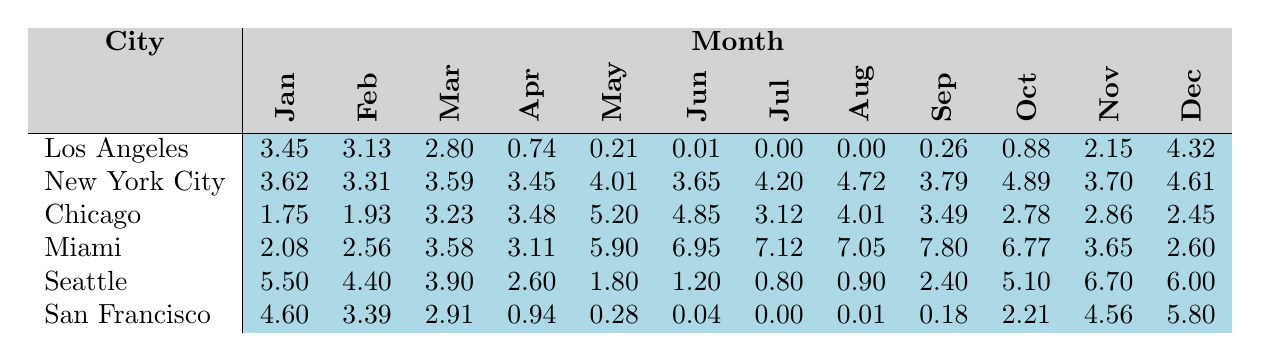What is the total precipitation in Miami during the summer months (June, July, August)? To find the total precipitation in Miami during the summer months, we add the precipitation values for June (6.95), July (7.12), and August (7.05). Summing these gives us 6.95 + 7.12 + 7.05 = 21.12 inches.
Answer: 21.12 Which city had the highest precipitation in December? Looking at the December column for each city, Miami had 2.60, Los Angeles had 4.32, New York City had 4.61, Chicago had 2.45, Seattle had 6.00, and San Francisco had 5.80. The highest value is 6.00 from Seattle.
Answer: Seattle What is the average monthly precipitation for Chicago in 2022? We add the monthly precipitation values for Chicago: 1.75 + 1.93 + 3.23 + 3.48 + 5.20 + 4.85 + 3.12 + 4.01 + 3.49 + 2.78 + 2.86 + 2.45 = 36.42. Since there are 12 months, we divide this sum by 12 to find the average: 36.42 / 12 = 3.035 inches.
Answer: 3.035 Did San Francisco have more precipitation in November than in June? The November precipitation for San Francisco is 4.56 inches, while June's is 0.04 inches. Since 4.56 > 0.04, San Francisco had more precipitation in November than in June.
Answer: Yes Which city experienced the least amount of rainfall in July? Checking the July precipitation values: Los Angeles (0.00), New York City (4.20), Chicago (3.12), Miami (7.12), Seattle (0.80), and San Francisco (0.00). Los Angeles and San Francisco both had 0.00 inches, which is the least.
Answer: Los Angeles and San Francisco 